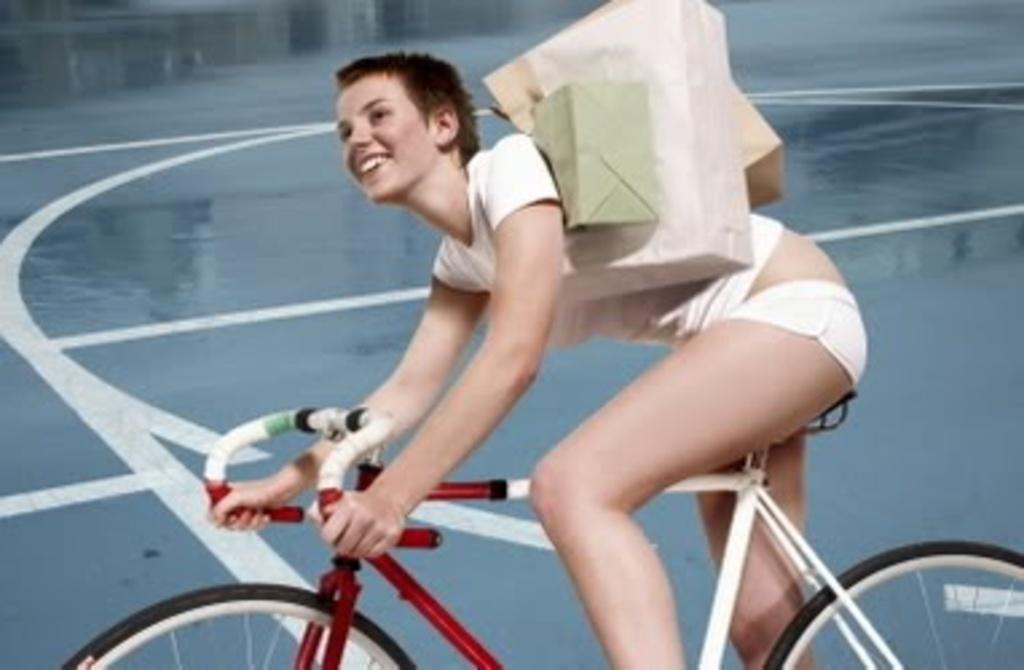Describe this image in one or two sentences. Here is the woman sitting and holding the bicycle. These are the bags holded by the women. Background is blue in color. 